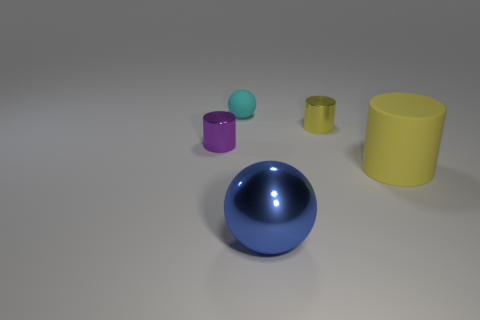Does the big yellow rubber thing have the same shape as the yellow object that is behind the large yellow cylinder?
Provide a short and direct response. Yes. What number of shiny things are both behind the large blue shiny thing and to the right of the small cyan thing?
Offer a very short reply. 1. Are the small yellow object and the sphere that is behind the large yellow matte cylinder made of the same material?
Your response must be concise. No. Are there the same number of small purple shiny things on the right side of the large sphere and large red spheres?
Give a very brief answer. Yes. There is a rubber thing that is behind the big yellow rubber cylinder; what is its color?
Provide a short and direct response. Cyan. What number of other objects are there of the same color as the large matte cylinder?
Provide a succinct answer. 1. Is the size of the metallic cylinder left of the matte sphere the same as the tiny ball?
Provide a short and direct response. Yes. What material is the yellow object in front of the purple metal cylinder?
Your response must be concise. Rubber. How many metallic objects are large yellow cylinders or things?
Offer a very short reply. 3. Is the number of matte objects that are behind the tiny cyan sphere less than the number of large cyan rubber blocks?
Your answer should be compact. No. 